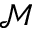Convert formula to latex. <formula><loc_0><loc_0><loc_500><loc_500>\mathcal { M }</formula> 